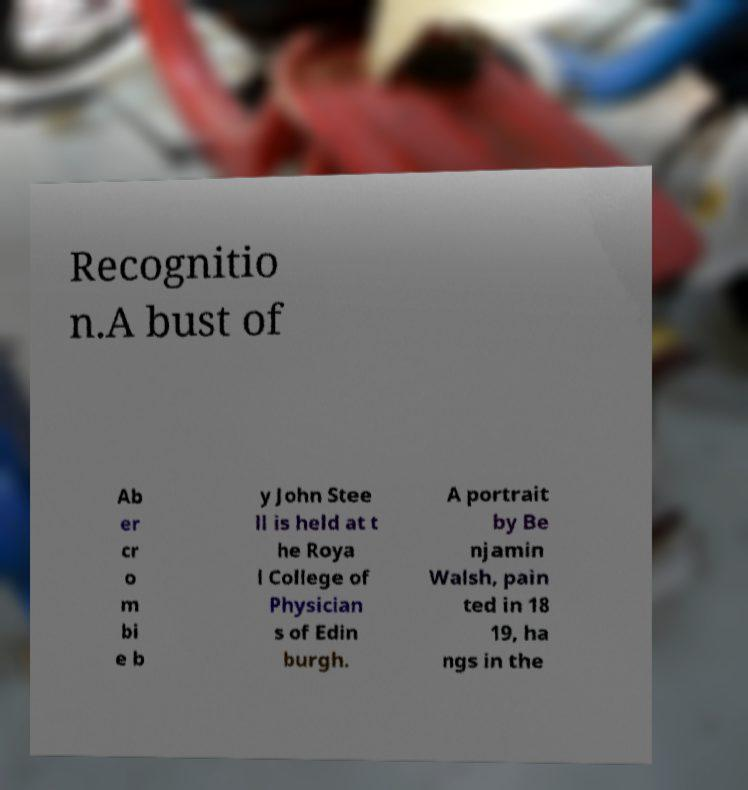For documentation purposes, I need the text within this image transcribed. Could you provide that? Recognitio n.A bust of Ab er cr o m bi e b y John Stee ll is held at t he Roya l College of Physician s of Edin burgh. A portrait by Be njamin Walsh, pain ted in 18 19, ha ngs in the 